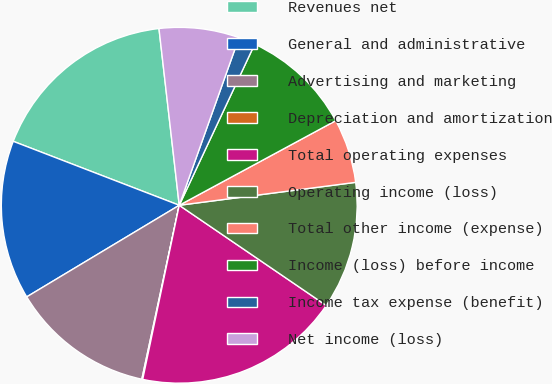Convert chart to OTSL. <chart><loc_0><loc_0><loc_500><loc_500><pie_chart><fcel>Revenues net<fcel>General and administrative<fcel>Advertising and marketing<fcel>Depreciation and amortization<fcel>Total operating expenses<fcel>Operating income (loss)<fcel>Total other income (expense)<fcel>Income (loss) before income<fcel>Income tax expense (benefit)<fcel>Net income (loss)<nl><fcel>17.33%<fcel>14.46%<fcel>13.02%<fcel>0.08%<fcel>18.77%<fcel>11.58%<fcel>5.83%<fcel>10.14%<fcel>1.52%<fcel>7.27%<nl></chart> 